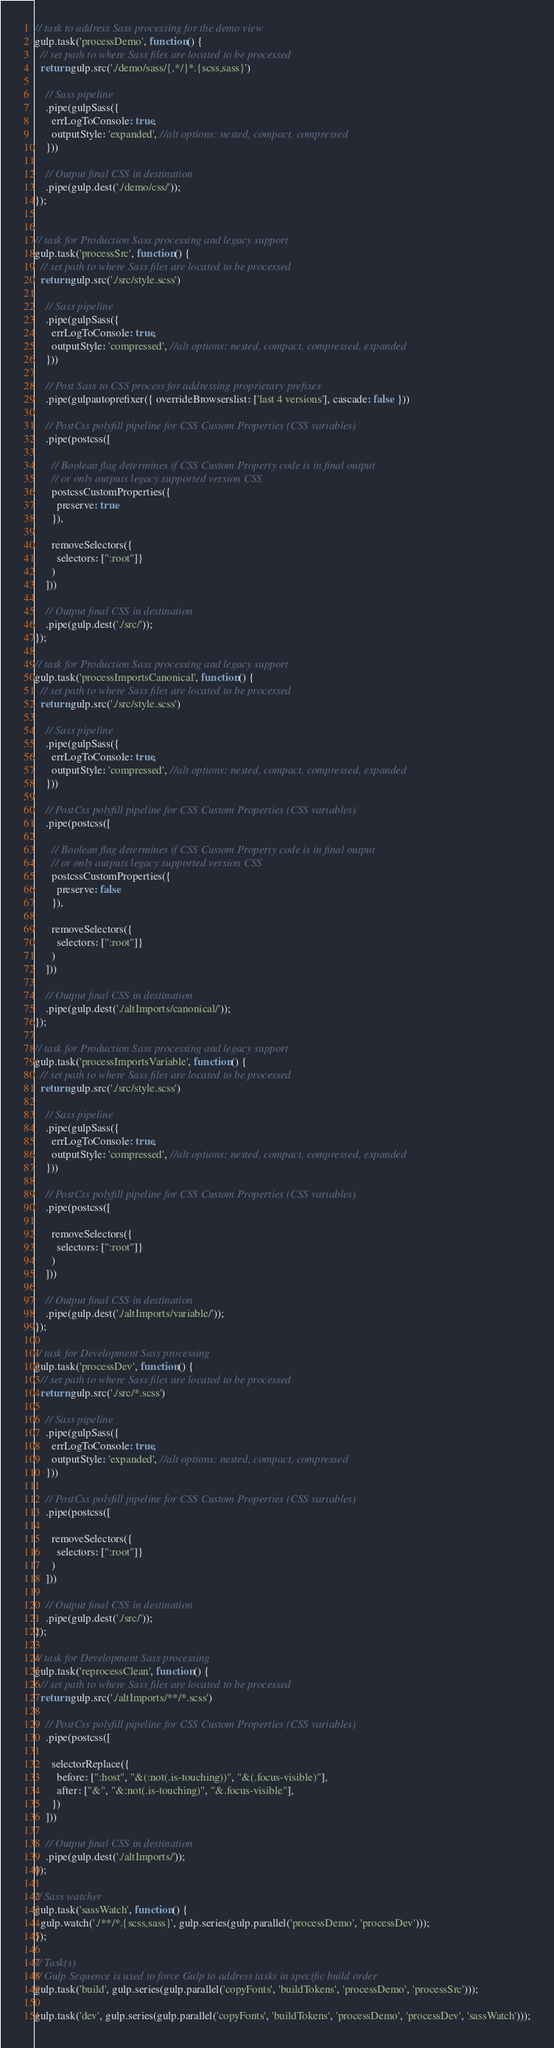Convert code to text. <code><loc_0><loc_0><loc_500><loc_500><_JavaScript_>
// task to address Sass processing for the demo view
gulp.task('processDemo', function() {
  // set path to where Sass files are located to be processed
  return gulp.src('./demo/sass/{,*/}*.{scss,sass}')

    // Sass pipeline
    .pipe(gulpSass({
      errLogToConsole: true,
      outputStyle: 'expanded', //alt options: nested, compact, compressed
    }))

    // Output final CSS in destination
    .pipe(gulp.dest('./demo/css/'));
});


// task for Production Sass processing and legacy support
gulp.task('processSrc', function() {
  // set path to where Sass files are located to be processed
  return gulp.src('./src/style.scss')

    // Sass pipeline
    .pipe(gulpSass({
      errLogToConsole: true,
      outputStyle: 'compressed', //alt options: nested, compact, compressed, expanded
    }))

    // Post Sass to CSS process for addressing proprietary prefixes
    .pipe(gulpautoprefixer({ overrideBrowserslist: ['last 4 versions'], cascade: false }))

    // PostCss polyfill pipeline for CSS Custom Properties (CSS variables)
    .pipe(postcss([

      // Boolean flag determines if CSS Custom Property code is in final output
      // or only outputs legacy supported version CSS
      postcssCustomProperties({
        preserve: true
      }),

      removeSelectors({
        selectors: [":root"]}
      )
    ]))

    // Output final CSS in destination
    .pipe(gulp.dest('./src/'));
});

// task for Production Sass processing and legacy support
gulp.task('processImportsCanonical', function() {
  // set path to where Sass files are located to be processed
  return gulp.src('./src/style.scss')

    // Sass pipeline
    .pipe(gulpSass({
      errLogToConsole: true,
      outputStyle: 'compressed', //alt options: nested, compact, compressed, expanded
    }))

    // PostCss polyfill pipeline for CSS Custom Properties (CSS variables)
    .pipe(postcss([

      // Boolean flag determines if CSS Custom Property code is in final output
      // or only outputs legacy supported version CSS
      postcssCustomProperties({
        preserve: false
      }),

      removeSelectors({
        selectors: [":root"]}
      )
    ]))

    // Output final CSS in destination
    .pipe(gulp.dest('./altImports/canonical/'));
});

// task for Production Sass processing and legacy support
gulp.task('processImportsVariable', function() {
  // set path to where Sass files are located to be processed
  return gulp.src('./src/style.scss')

    // Sass pipeline
    .pipe(gulpSass({
      errLogToConsole: true,
      outputStyle: 'compressed', //alt options: nested, compact, compressed, expanded
    }))

    // PostCss polyfill pipeline for CSS Custom Properties (CSS variables)
    .pipe(postcss([

      removeSelectors({
        selectors: [":root"]}
      )
    ]))

    // Output final CSS in destination
    .pipe(gulp.dest('./altImports/variable/'));
});

// task for Development Sass processing
gulp.task('processDev', function() {
  // set path to where Sass files are located to be processed
  return gulp.src('./src/*.scss')

    // Sass pipeline
    .pipe(gulpSass({
      errLogToConsole: true,
      outputStyle: 'expanded', //alt options: nested, compact, compressed
    }))

    // PostCss polyfill pipeline for CSS Custom Properties (CSS variables)
    .pipe(postcss([

      removeSelectors({
        selectors: [":root"]}
      )
    ]))

    // Output final CSS in destination
    .pipe(gulp.dest('./src/'));
});

// task for Development Sass processing
gulp.task('reprocessClean', function() {
  // set path to where Sass files are located to be processed
  return gulp.src('./altImports/**/*.scss')

    // PostCss polyfill pipeline for CSS Custom Properties (CSS variables)
    .pipe(postcss([

      selectorReplace({
        before: [":host", "&(:not(.is-touching))", "&(.focus-visible)"],
        after: ["&", "&:not(.is-touching)", "&.focus-visible"],
      })
    ]))

    // Output final CSS in destination
    .pipe(gulp.dest('./altImports/'));
});

// Sass watcher
gulp.task('sassWatch', function() {
  gulp.watch('./**/*.{scss,sass}', gulp.series(gulp.parallel('processDemo', 'processDev')));
});

// Task(s)
// Gulp Sequence is used to force Gulp to address tasks in specific build order
gulp.task('build', gulp.series(gulp.parallel('copyFonts', 'buildTokens', 'processDemo', 'processSrc')));

gulp.task('dev', gulp.series(gulp.parallel('copyFonts', 'buildTokens', 'processDemo', 'processDev', 'sassWatch')));
</code> 